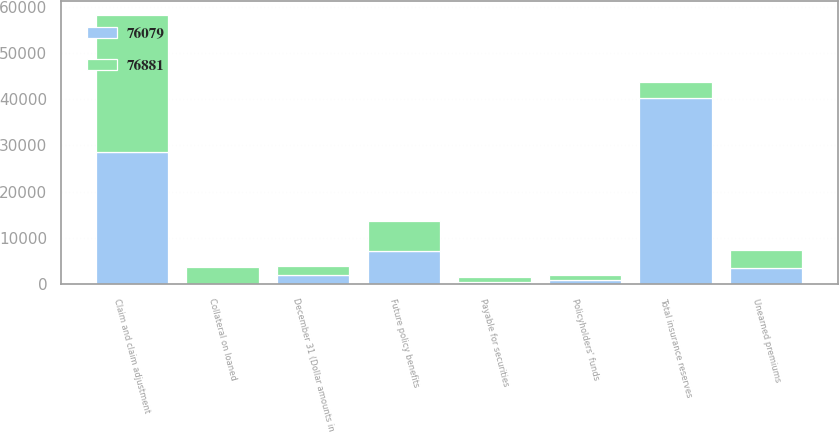Convert chart. <chart><loc_0><loc_0><loc_500><loc_500><stacked_bar_chart><ecel><fcel>December 31 (Dollar amounts in<fcel>Claim and claim adjustment<fcel>Future policy benefits<fcel>Unearned premiums<fcel>Policyholders' funds<fcel>Total insurance reserves<fcel>Payable for securities<fcel>Collateral on loaned<nl><fcel>76079<fcel>2007<fcel>28588<fcel>7106<fcel>3597<fcel>930<fcel>40221<fcel>544<fcel>63<nl><fcel>76881<fcel>2006<fcel>29636<fcel>6645<fcel>3784<fcel>1015<fcel>3597<fcel>1047<fcel>3602<nl></chart> 